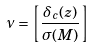Convert formula to latex. <formula><loc_0><loc_0><loc_500><loc_500>\nu = \left [ \frac { \delta _ { c } ( z ) } { \sigma ( M ) } \right ]</formula> 